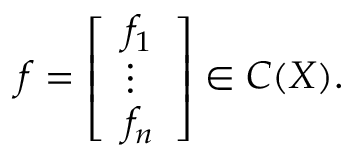<formula> <loc_0><loc_0><loc_500><loc_500>f = { \left [ \begin{array} { l } { f _ { 1 } } \\ { \vdots } \\ { f _ { n } } \end{array} \right ] } \in C ( X ) .</formula> 